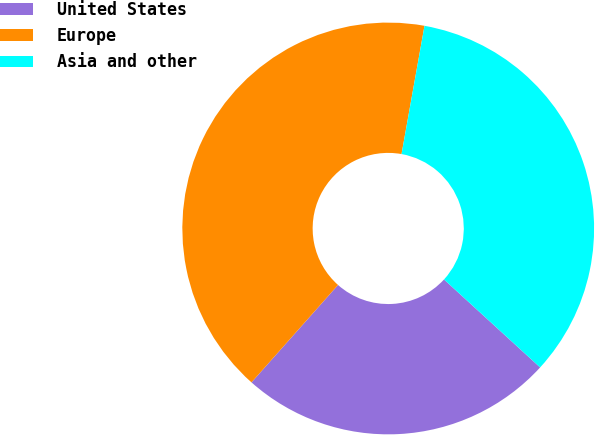<chart> <loc_0><loc_0><loc_500><loc_500><pie_chart><fcel>United States<fcel>Europe<fcel>Asia and other<nl><fcel>24.77%<fcel>41.26%<fcel>33.97%<nl></chart> 